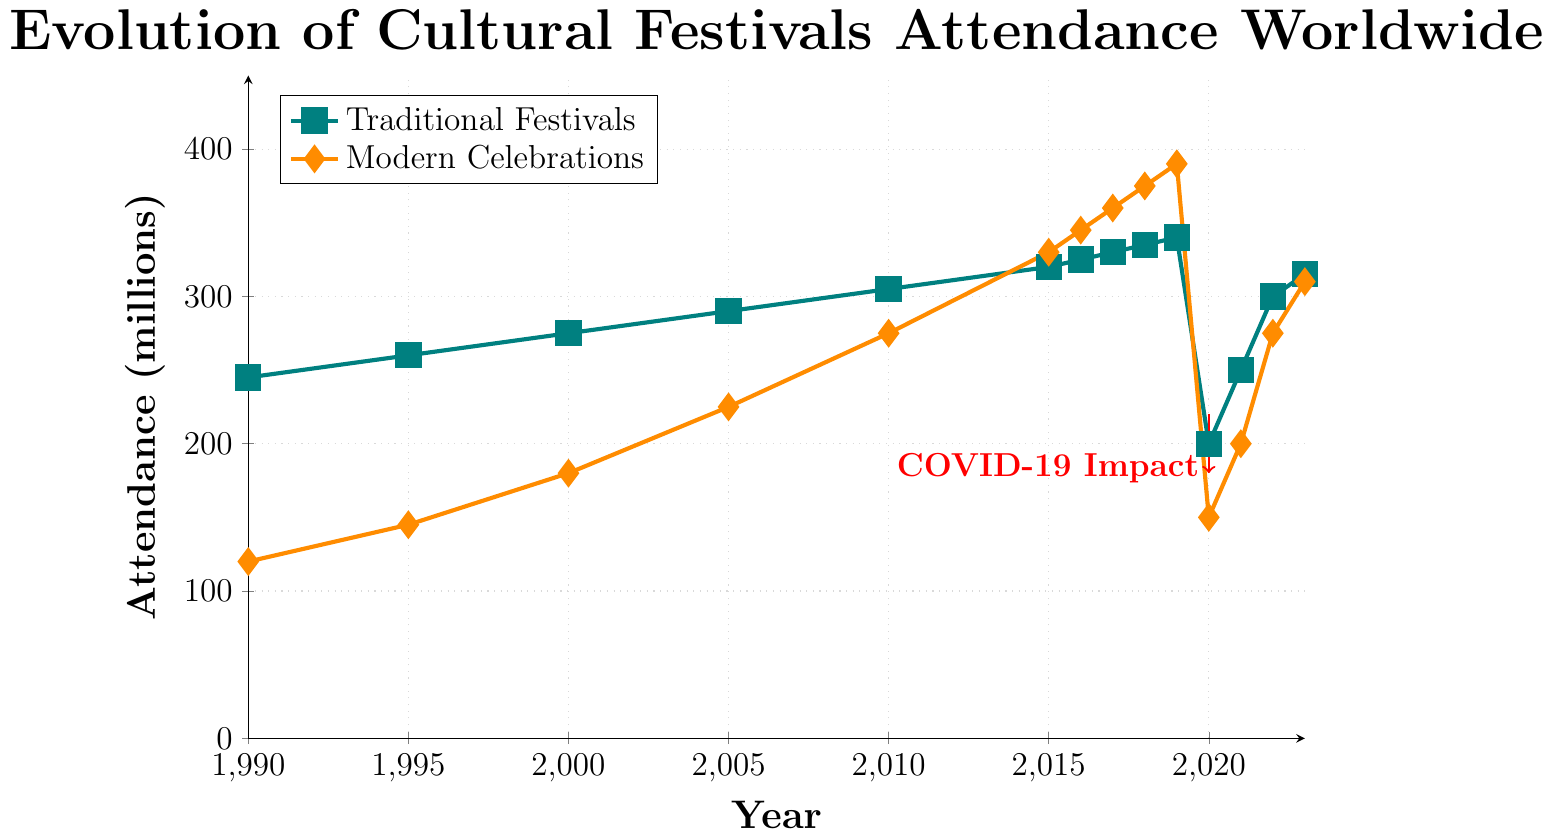What year marked the intersection point where attendance for modern celebrations surpassed traditional festivals? Compare the attendance between traditional festivals and modern celebrations over the years to find the point where modern celebrations first exceed. The year is 2015 when modern celebrations reached 330 million while traditional festivals were at 320 million.
Answer: 2015 Which category saw a larger drop in attendance during the year 2020, and by how much? Identify the attendance decline from 2019 to 2020 for both categories. Traditional festivals dropped from 340 million in 2019 to 200 million in 2020 (a decrease of 140 million), while modern celebrations declined from 390 million in 2019 to 150 million in 2020 (a decrease of 240 million).
Answer: Modern celebrations, 240 million What was the average attendance for traditional festivals from 2010 to 2019? List the attendance values for traditional festivals from 2010 to 2019: 305, 320, 325, 330, 335, 340. Sum these values: 305 + 320 + 325 + 330 + 335 + 340 = 1955. Divide by the number of years (10).
Answer: 326 million How did the attendance for traditional festivals change during the COVID-19 pandemic years (2020-2021)? Look at the attendance values for traditional festivals in 2020 and 2021, which are 200 million and 250 million respectively. The change is 250 - 200 = 50 million.
Answer: Increased by 50 million Which year saw the highest attendance for modern celebrations, and what was the attendance figure? Check the attendance values for modern celebrations each year and confirm the highest value. The highest attendance is in 2019 with 390 million.
Answer: 2019, 390 million 